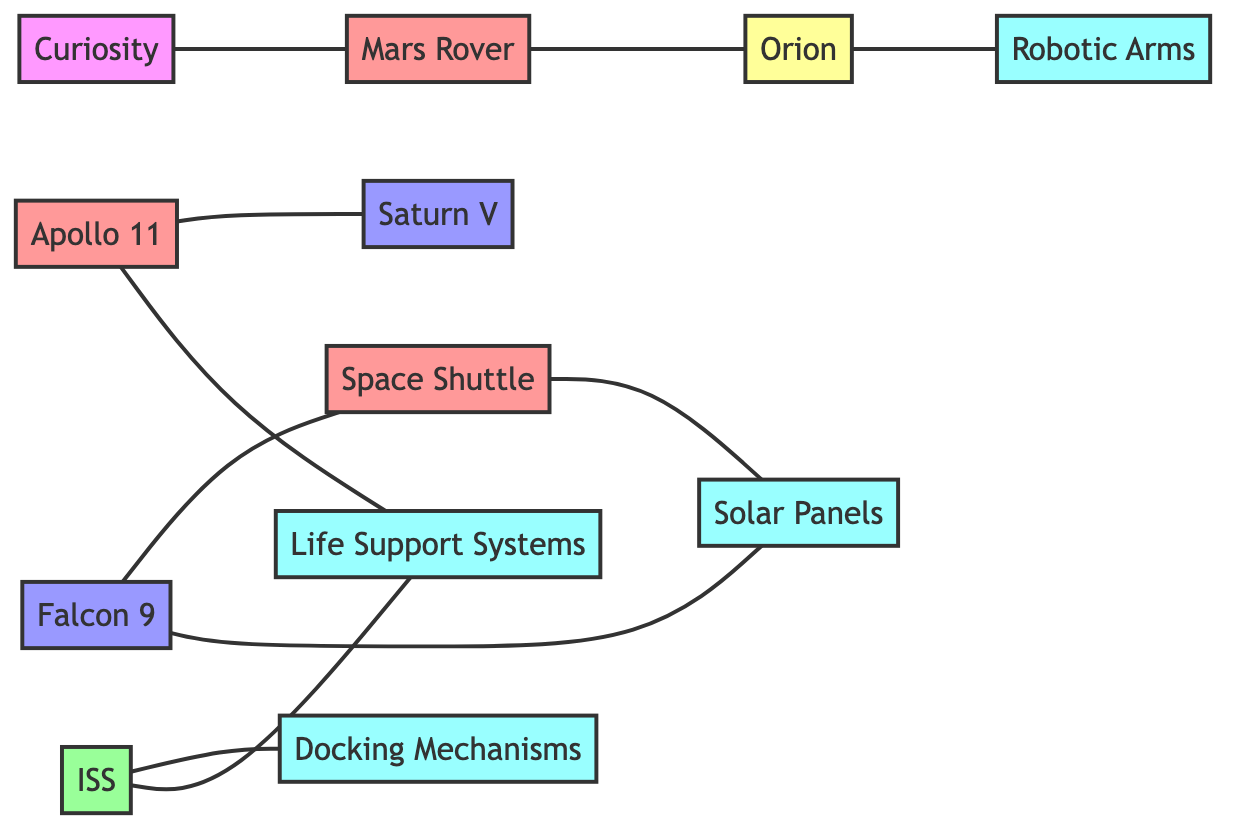What's the total number of nodes in the graph? There are 11 nodes listed in the data: Apollo 11, Space Shuttle, Mars Rover, ISS, Saturn V, Falcon 9, Orion, Curiosity, Solar Panels, Life Support Systems, and Docking Mechanisms. Counting all of them gives a total of 11 nodes.
Answer: 11 Which launch vehicle launched Apollo 11? The relationship stated in the diagram indicates that Apollo 11 is launched by Saturn V. This is explicitly mentioned as a connection between the two nodes.
Answer: Saturn V What technology do both the ISS and Apollo 11 utilize? The diagram shows that both ISS and Apollo 11 are connected to Life Support Systems. Apollo 11 pioneered the technology, while ISS is equipped with it, indicating a relationship between them.
Answer: Life Support Systems How many technologies are mentioned in the diagram? The technologies listed are Solar Panels, Life Support Systems, Docking Mechanisms, and Robotic Arms, totaling four. By counting each technology node, the total is four.
Answer: 4 Which spacecraft has demonstrated Mars Rover technology? The graph links Mars Rover with Orion, stating that Mars Rover is demonstrated by Orion. Therefore, Orion is identified as the spacecraft that demonstrated this rover technology.
Answer: Orion Which mission does Falcon 9 succeed? The connection labeled "successor to" indicates that Falcon 9 is the successor to the Space Shuttle, as shown in the diagram.
Answer: Space Shuttle What is a relationship between the Curiosity and Mars Rover nodes? The diagram indicates that Curiosity is part of the Mars Rover, creating a direct relationship between these two nodes.
Answer: part_of How many direct connections are there for the ISS? The ISS has two direct connections in the diagram: one to Docking Mechanisms and another to Life Support Systems, making a total of two connections.
Answer: 2 Which technology is equipped in Orion? The diagram shows that Orion is equipped with Robotic Arms, providing a direct connection between these two nodes.
Answer: Robotic Arms 